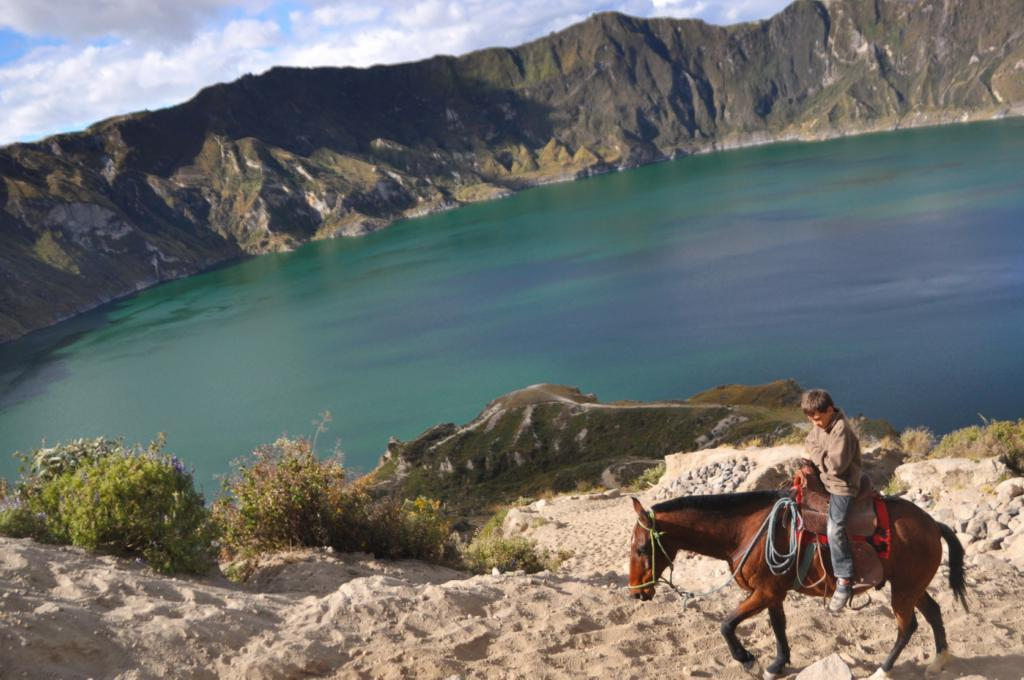What is the person in the image doing? The person is sitting on a horse in the image. What can be seen beneath the horse and person? The ground is visible in the image. What type of vegetation is present in the image? There is grass and plants visible in the image. What natural feature can be seen in the distance? There is a mountain in the image. What is visible in the background of the image? The sky is visible in the background of the image. What can be seen in the sky? Clouds are present in the sky. What type of plastic toy is being used by the person on the horse in the image? There is no plastic toy present in the image; the person is sitting on a horse. 